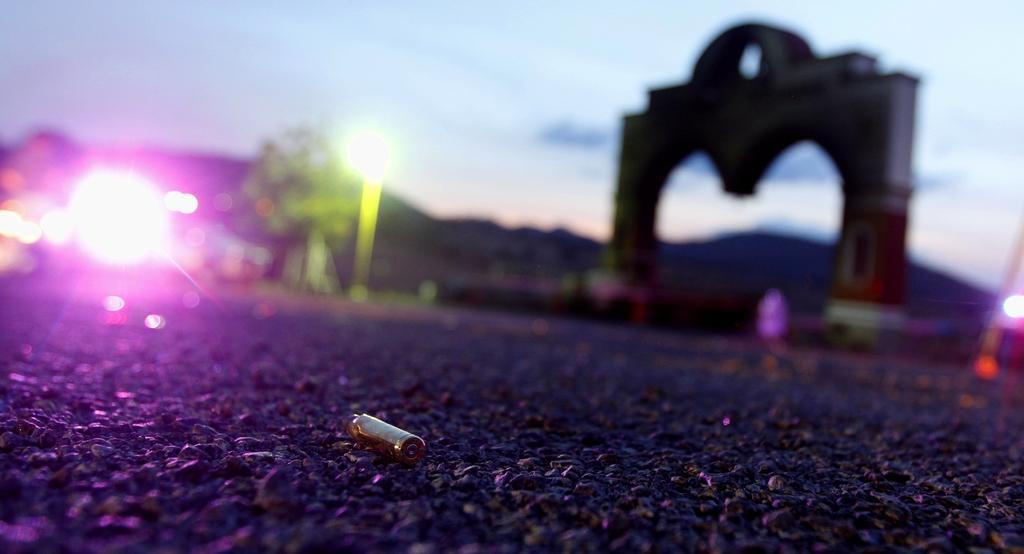Can you describe this image briefly? In this image there is a battery on the road. On the right side of the image there is an arch. There are lights. There are trees. In the background of the image there are mountains and sky. 